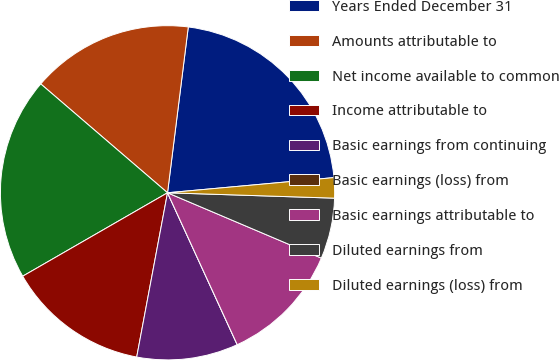Convert chart. <chart><loc_0><loc_0><loc_500><loc_500><pie_chart><fcel>Years Ended December 31<fcel>Amounts attributable to<fcel>Net income available to common<fcel>Income attributable to<fcel>Basic earnings from continuing<fcel>Basic earnings (loss) from<fcel>Basic earnings attributable to<fcel>Diluted earnings from<fcel>Diluted earnings (loss) from<nl><fcel>21.57%<fcel>15.69%<fcel>19.61%<fcel>13.73%<fcel>9.8%<fcel>0.0%<fcel>11.76%<fcel>5.88%<fcel>1.96%<nl></chart> 